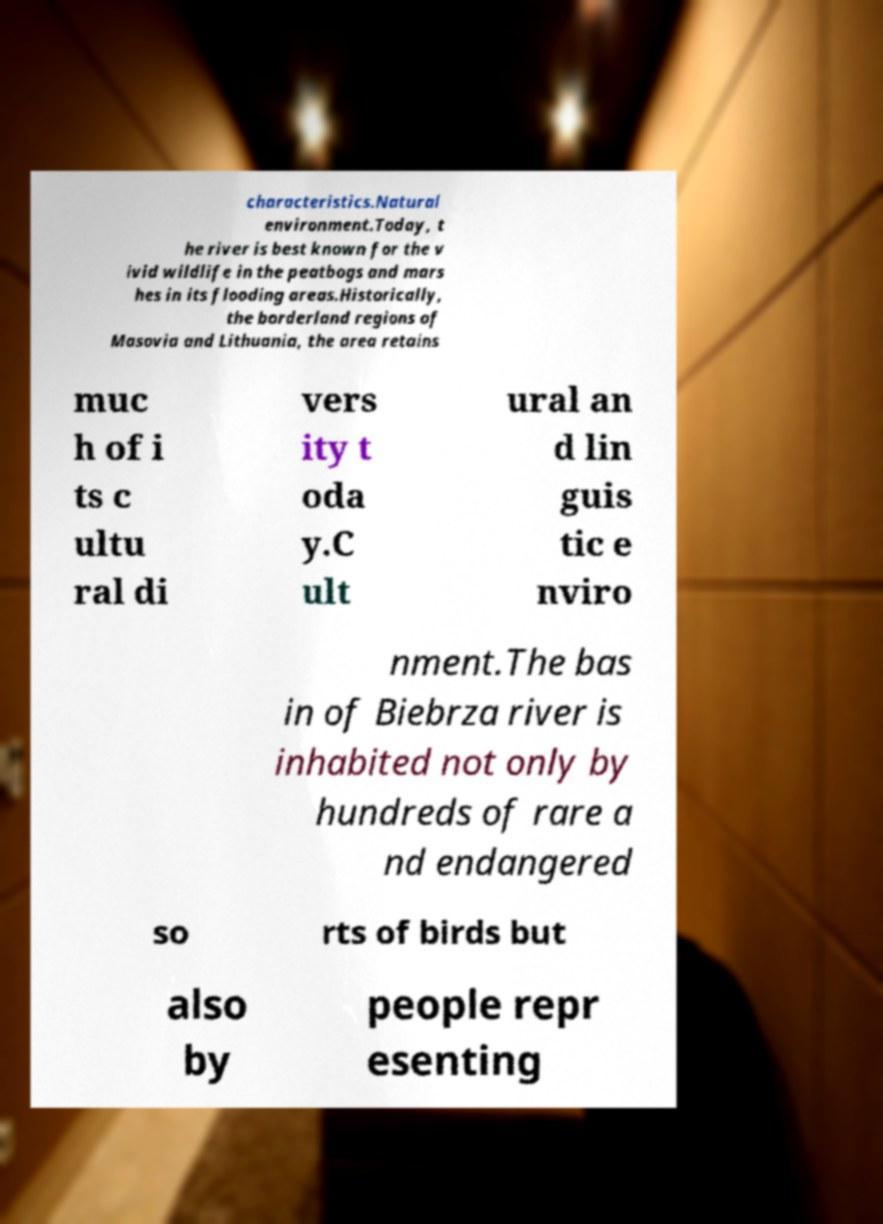Could you extract and type out the text from this image? characteristics.Natural environment.Today, t he river is best known for the v ivid wildlife in the peatbogs and mars hes in its flooding areas.Historically, the borderland regions of Masovia and Lithuania, the area retains muc h of i ts c ultu ral di vers ity t oda y.C ult ural an d lin guis tic e nviro nment.The bas in of Biebrza river is inhabited not only by hundreds of rare a nd endangered so rts of birds but also by people repr esenting 